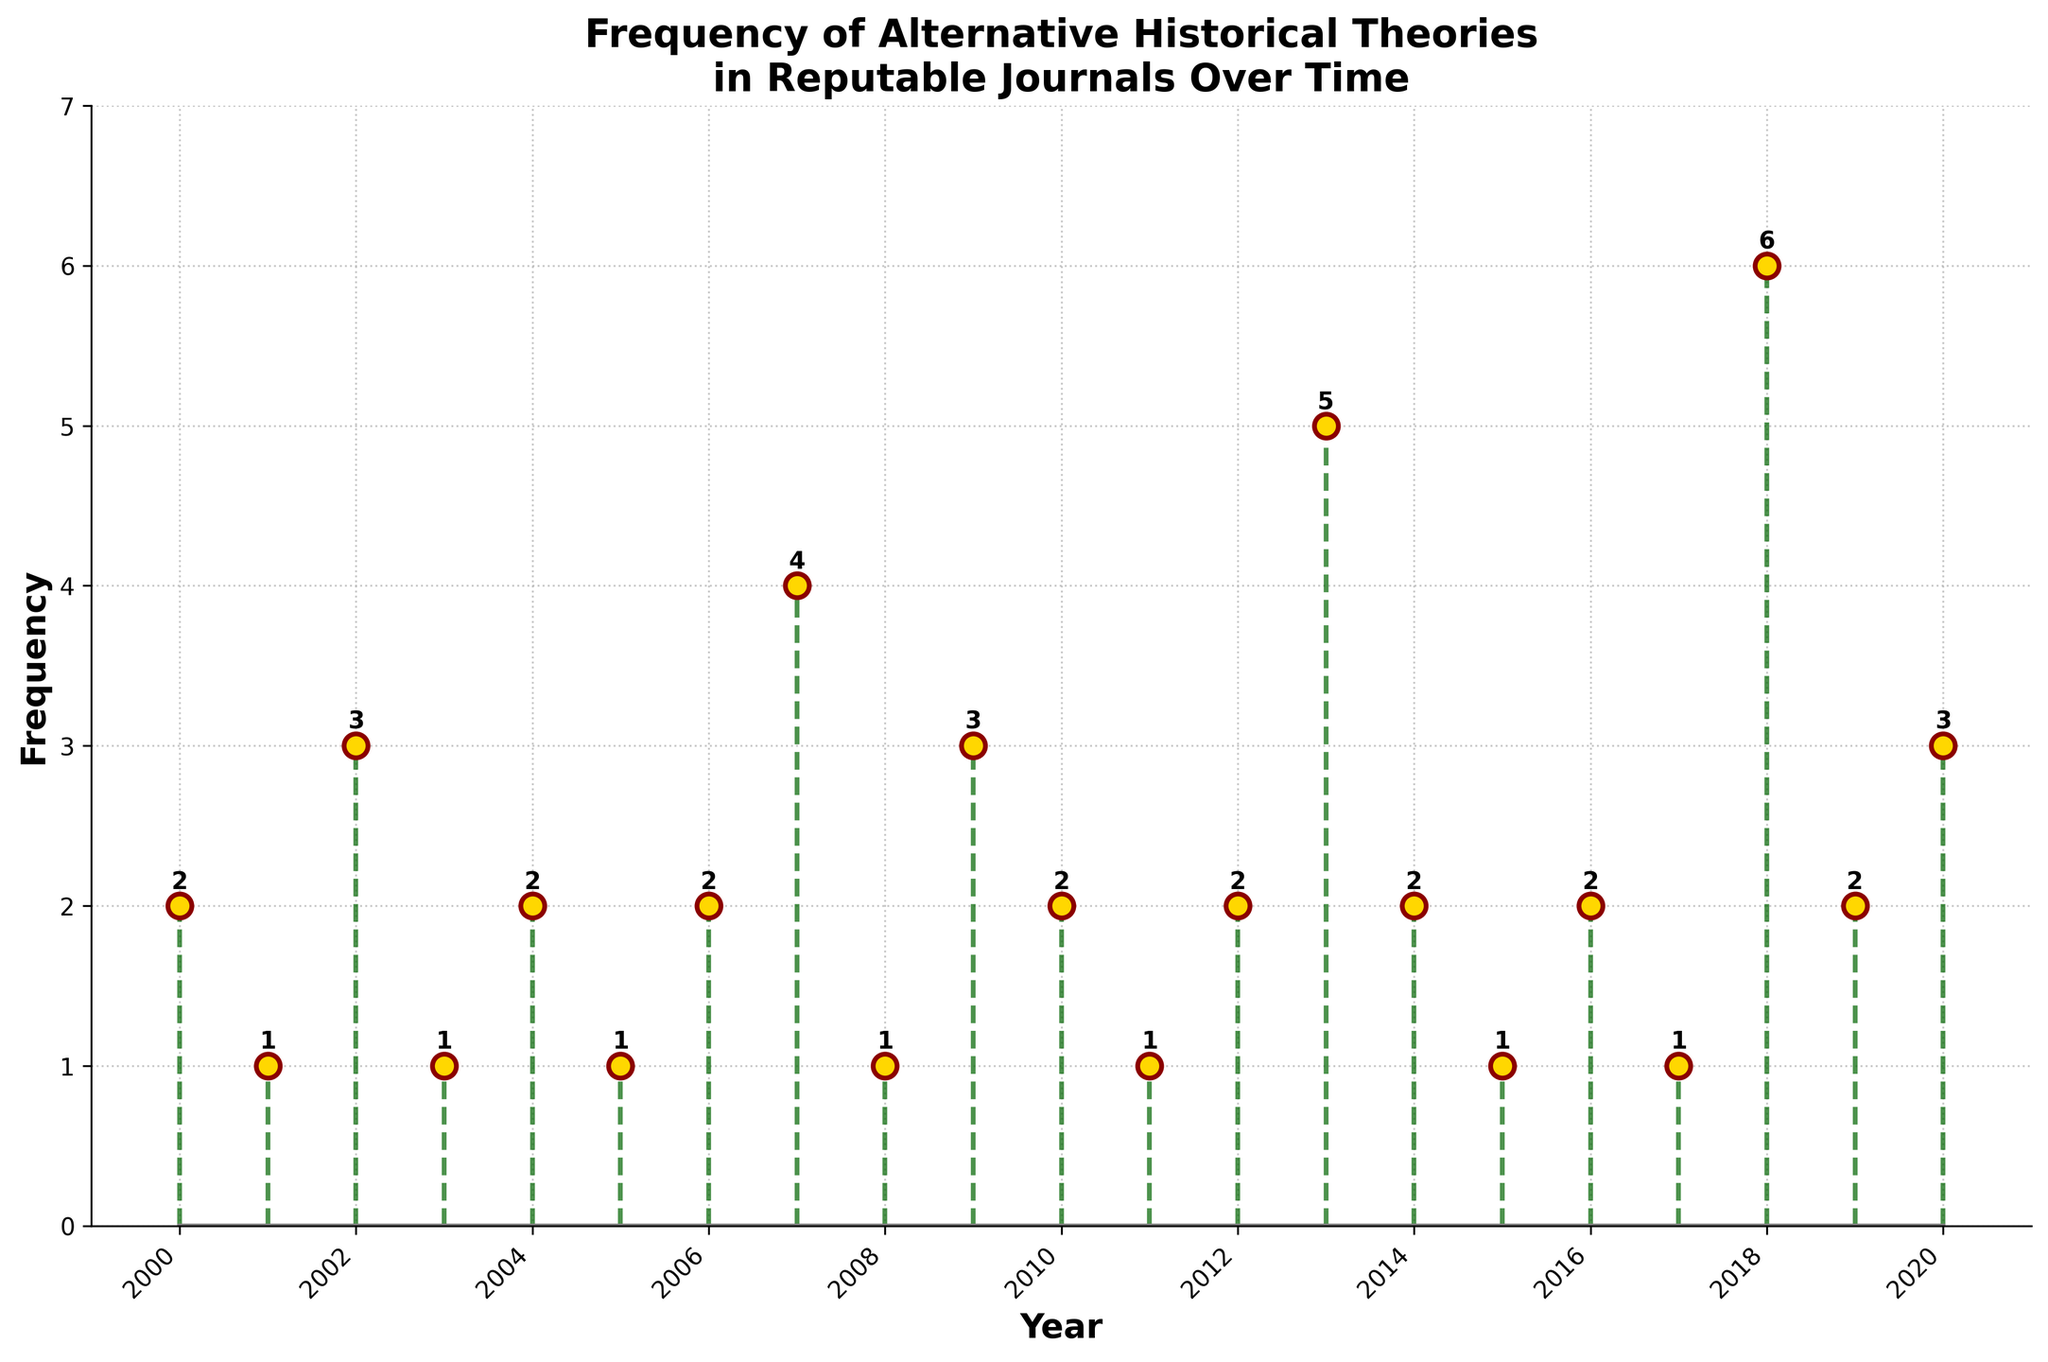What is the title of the figure? The title is displayed at the top of the figure, generally summarizing the entire content shown.
Answer: Frequency of Alternative Historical Theories in Reputable Journals Over Time What are the colors of the stem lines and the markers? By observing the figure, one can see the specific colors used in the lines and markers. The stem lines are green while the markers have dark red edges filled with gold.
Answer: Dark green and gold (with dark red edges) What is the frequency of publications in the year 2018? Locate the year 2018 on the x-axis, then follow it vertically to the point and stem to read the frequency. The frequency for 2018 is indicated as 6.
Answer: 6 Which year recorded the highest frequency of publications? Compare the lengths of all the stems visually. The year with the tallest stem corresponds to the highest frequency. 2018 has the highest stem with a frequency of 6.
Answer: 2018 What is the average frequency of publications from 2007 to 2012? Sum the frequencies from years 2007 to 2012 and divide by the number of years. (4 + 1 + 3 + 2 + 1 + 2) / 6 = 13 / 6
Answer: 2.17 Which journal had a publication frequency of 5, and in which year? Locate the point with a frequency of 5 and look at the corresponding year on the x-axis. Then identify the journal from that year. The frequency of 5 is in 2013, and the journal is Historiography Today.
Answer: Historiography Today in 2013 Is there any year where the publication frequency was the same for two different journals? Scan the figure to find years with identical heights of stems, indicating the same frequency. Both Journal of Egyptian History and Historical Review Quarterly had a frequency of 2 in 2012.
Answer: 2012 What is the sum of frequencies for the years 2004, 2009, and 2016? Add the frequencies from these specific years. 2 (2004) + 3 (2009) + 2 (2016) = 7
Answer: 7 How many times did 'Historiography Today' exceed 3 publications in a year? Examine the publication frequencies specifically for 'Historiography Today' for each year. It exceeded 3 publications in 2007, 2013, and 2018 which counts to 3 times.
Answer: 3 Was the frequency of publications ever 0 for any year? By examining the vertical stems, it’s clear that every year has at least one publication, as indicated by the points' positions above the baseline.
Answer: No 